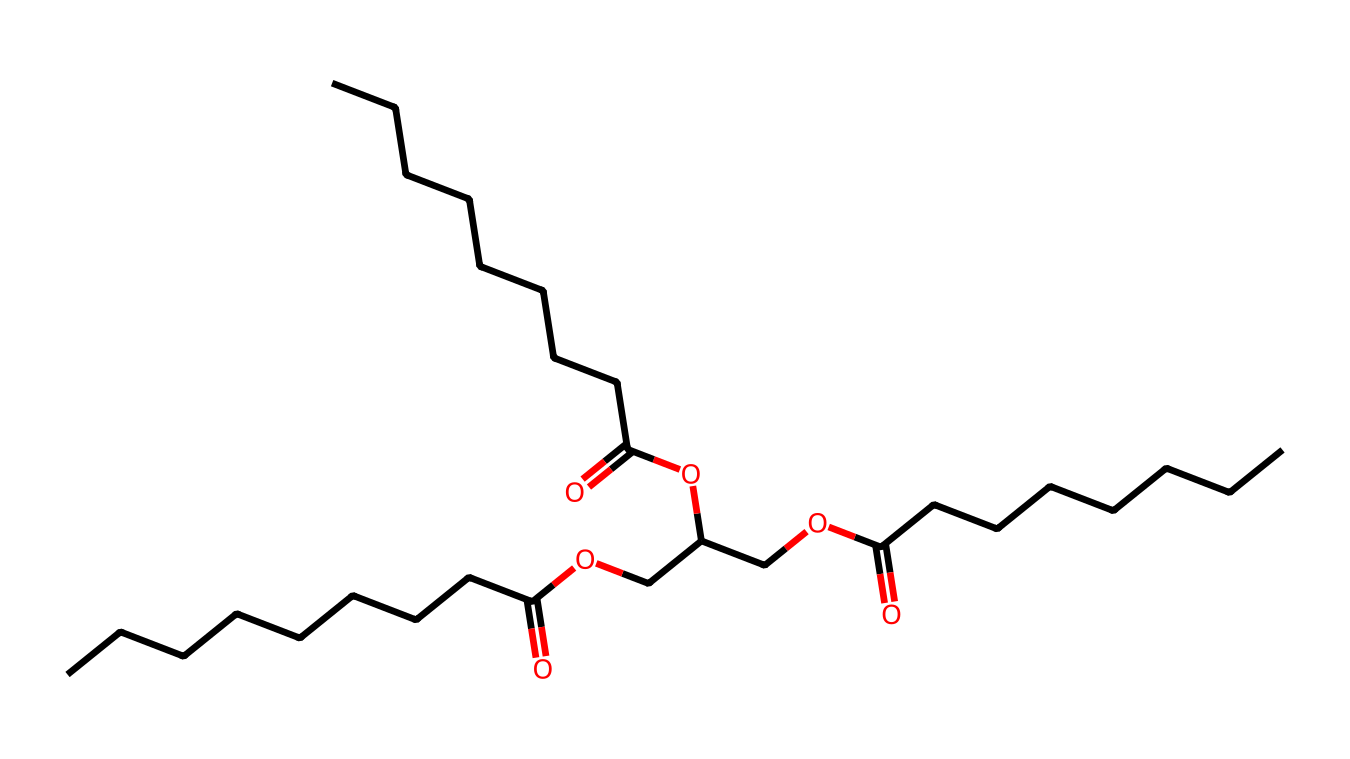How many carbon atoms are in this structure? The SMILES representation indicates chains of carbon atoms, specifically counting the 'C' notation indicates the number of carbon atoms. There are a total of 18 carbon atoms in the structure.
Answer: 18 What type of glyceride is represented in this chemical structure? The presence of both ester linkages and a glycerol backbone indicates that this is a triglyceride, as triglycerides are composed of a glycerol and three fatty acids.
Answer: triglyceride How many ester bonds are present in the structure? By analyzing the connections, each fatty acid chain is connected through ester bonds to the glycerol backbone. In this structure, there are three ester bonds connecting the three fatty acid chains to the glycerol molecule.
Answer: 3 What functional groups are present in this chemical? Looking at the SMILES representation, the presence of 'OC(=O)' indicates ester functional groups, while 'CCCCCCCC(=O)' shows that there are also acyl groups, confirming that both ester and carboxylic acid functional groups are present.
Answer: ester, carboxylic acid Does this chemical structure indicate that it is saturated or unsaturated? The structure contains only single bonds between carbon atoms as indicated by the absence of double bonds in the carbon chains, which suggests that all fatty acids in this triglyceride are saturated.
Answer: saturated 